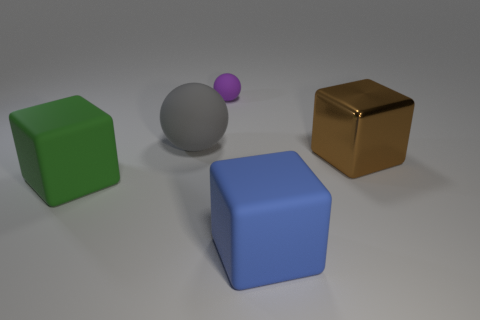What number of other objects are the same size as the purple sphere? Upon visually inspecting the image, there are no other objects that are the exact same size as the small purple sphere. Each object in the scene appears to have its own unique size. 